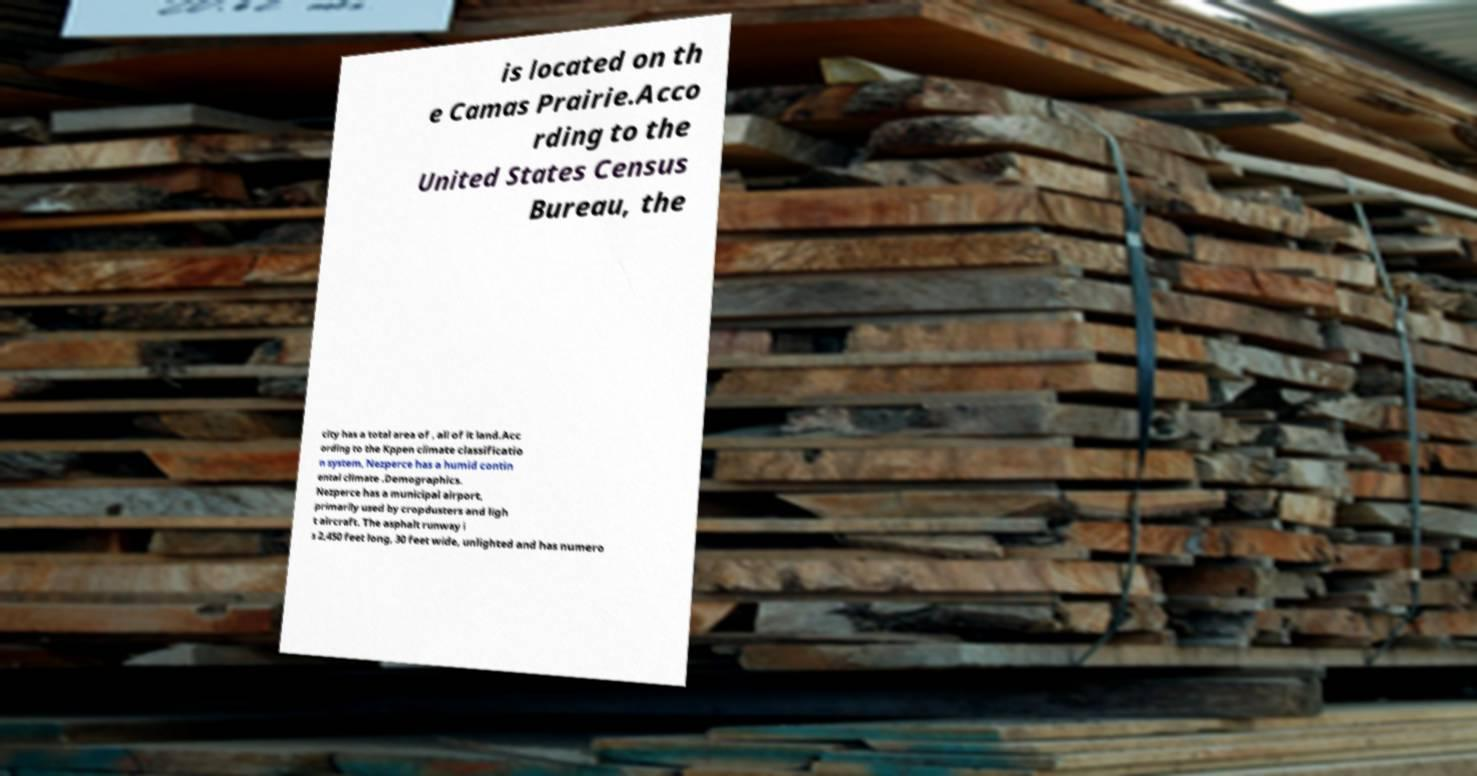Please identify and transcribe the text found in this image. is located on th e Camas Prairie.Acco rding to the United States Census Bureau, the city has a total area of , all of it land.Acc ording to the Kppen climate classificatio n system, Nezperce has a humid contin ental climate .Demographics. Nezperce has a municipal airport, primarily used by cropdusters and ligh t aircraft. The asphalt runway i s 2,450 feet long, 30 feet wide, unlighted and has numero 